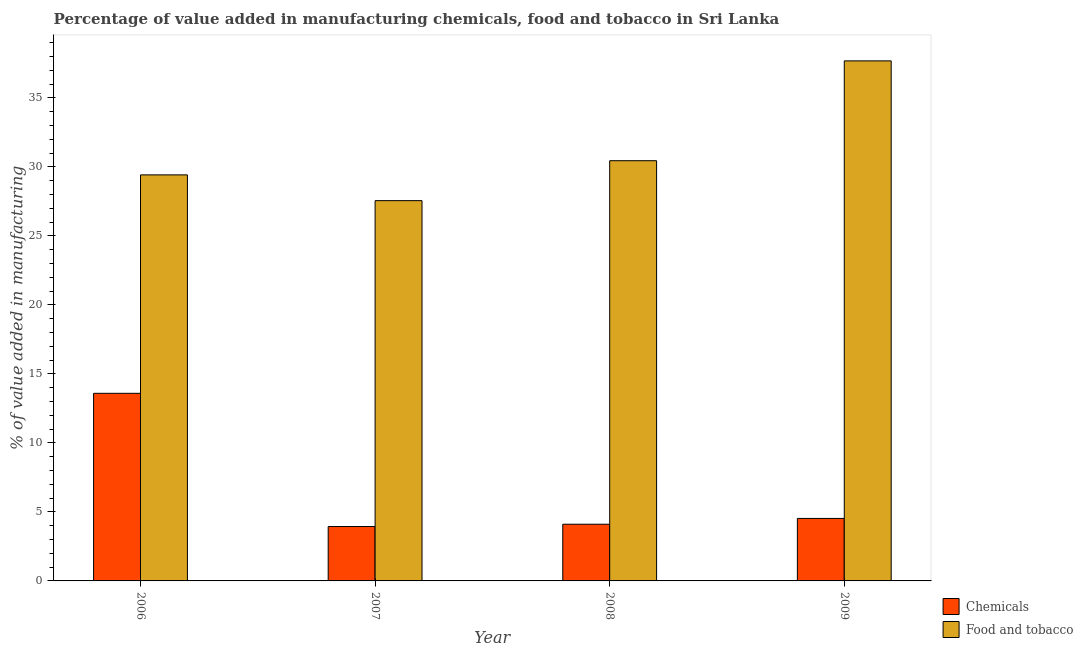Are the number of bars on each tick of the X-axis equal?
Offer a very short reply. Yes. How many bars are there on the 2nd tick from the left?
Give a very brief answer. 2. What is the label of the 1st group of bars from the left?
Give a very brief answer. 2006. In how many cases, is the number of bars for a given year not equal to the number of legend labels?
Your response must be concise. 0. What is the value added by  manufacturing chemicals in 2007?
Your answer should be compact. 3.94. Across all years, what is the maximum value added by  manufacturing chemicals?
Keep it short and to the point. 13.59. Across all years, what is the minimum value added by  manufacturing chemicals?
Provide a succinct answer. 3.94. In which year was the value added by manufacturing food and tobacco maximum?
Provide a short and direct response. 2009. In which year was the value added by manufacturing food and tobacco minimum?
Your response must be concise. 2007. What is the total value added by  manufacturing chemicals in the graph?
Your answer should be very brief. 26.17. What is the difference between the value added by  manufacturing chemicals in 2007 and that in 2009?
Make the answer very short. -0.59. What is the difference between the value added by  manufacturing chemicals in 2008 and the value added by manufacturing food and tobacco in 2007?
Make the answer very short. 0.17. What is the average value added by  manufacturing chemicals per year?
Provide a short and direct response. 6.54. In the year 2009, what is the difference between the value added by manufacturing food and tobacco and value added by  manufacturing chemicals?
Make the answer very short. 0. In how many years, is the value added by manufacturing food and tobacco greater than 15 %?
Keep it short and to the point. 4. What is the ratio of the value added by manufacturing food and tobacco in 2006 to that in 2007?
Give a very brief answer. 1.07. Is the value added by  manufacturing chemicals in 2007 less than that in 2008?
Your answer should be compact. Yes. What is the difference between the highest and the second highest value added by  manufacturing chemicals?
Your answer should be very brief. 9.06. What is the difference between the highest and the lowest value added by manufacturing food and tobacco?
Provide a succinct answer. 10.13. Is the sum of the value added by  manufacturing chemicals in 2006 and 2009 greater than the maximum value added by manufacturing food and tobacco across all years?
Provide a short and direct response. Yes. What does the 1st bar from the left in 2007 represents?
Your answer should be very brief. Chemicals. What does the 1st bar from the right in 2008 represents?
Provide a short and direct response. Food and tobacco. How many bars are there?
Give a very brief answer. 8. Are all the bars in the graph horizontal?
Your answer should be very brief. No. Does the graph contain grids?
Keep it short and to the point. No. Where does the legend appear in the graph?
Provide a succinct answer. Bottom right. How are the legend labels stacked?
Give a very brief answer. Vertical. What is the title of the graph?
Make the answer very short. Percentage of value added in manufacturing chemicals, food and tobacco in Sri Lanka. Does "Under-5(female)" appear as one of the legend labels in the graph?
Your answer should be very brief. No. What is the label or title of the Y-axis?
Your answer should be compact. % of value added in manufacturing. What is the % of value added in manufacturing in Chemicals in 2006?
Keep it short and to the point. 13.59. What is the % of value added in manufacturing in Food and tobacco in 2006?
Provide a succinct answer. 29.42. What is the % of value added in manufacturing in Chemicals in 2007?
Make the answer very short. 3.94. What is the % of value added in manufacturing of Food and tobacco in 2007?
Keep it short and to the point. 27.55. What is the % of value added in manufacturing of Chemicals in 2008?
Provide a short and direct response. 4.11. What is the % of value added in manufacturing in Food and tobacco in 2008?
Your answer should be very brief. 30.45. What is the % of value added in manufacturing in Chemicals in 2009?
Offer a very short reply. 4.53. What is the % of value added in manufacturing of Food and tobacco in 2009?
Your response must be concise. 37.68. Across all years, what is the maximum % of value added in manufacturing in Chemicals?
Ensure brevity in your answer.  13.59. Across all years, what is the maximum % of value added in manufacturing in Food and tobacco?
Give a very brief answer. 37.68. Across all years, what is the minimum % of value added in manufacturing of Chemicals?
Ensure brevity in your answer.  3.94. Across all years, what is the minimum % of value added in manufacturing of Food and tobacco?
Make the answer very short. 27.55. What is the total % of value added in manufacturing in Chemicals in the graph?
Your answer should be compact. 26.17. What is the total % of value added in manufacturing of Food and tobacco in the graph?
Your answer should be compact. 125.1. What is the difference between the % of value added in manufacturing in Chemicals in 2006 and that in 2007?
Your answer should be very brief. 9.65. What is the difference between the % of value added in manufacturing in Food and tobacco in 2006 and that in 2007?
Your response must be concise. 1.87. What is the difference between the % of value added in manufacturing of Chemicals in 2006 and that in 2008?
Your answer should be very brief. 9.49. What is the difference between the % of value added in manufacturing in Food and tobacco in 2006 and that in 2008?
Your response must be concise. -1.03. What is the difference between the % of value added in manufacturing in Chemicals in 2006 and that in 2009?
Make the answer very short. 9.06. What is the difference between the % of value added in manufacturing in Food and tobacco in 2006 and that in 2009?
Your response must be concise. -8.26. What is the difference between the % of value added in manufacturing of Chemicals in 2007 and that in 2008?
Keep it short and to the point. -0.17. What is the difference between the % of value added in manufacturing of Food and tobacco in 2007 and that in 2008?
Your answer should be very brief. -2.89. What is the difference between the % of value added in manufacturing of Chemicals in 2007 and that in 2009?
Make the answer very short. -0.59. What is the difference between the % of value added in manufacturing of Food and tobacco in 2007 and that in 2009?
Provide a succinct answer. -10.13. What is the difference between the % of value added in manufacturing of Chemicals in 2008 and that in 2009?
Your response must be concise. -0.42. What is the difference between the % of value added in manufacturing of Food and tobacco in 2008 and that in 2009?
Your response must be concise. -7.23. What is the difference between the % of value added in manufacturing in Chemicals in 2006 and the % of value added in manufacturing in Food and tobacco in 2007?
Provide a succinct answer. -13.96. What is the difference between the % of value added in manufacturing in Chemicals in 2006 and the % of value added in manufacturing in Food and tobacco in 2008?
Offer a terse response. -16.85. What is the difference between the % of value added in manufacturing of Chemicals in 2006 and the % of value added in manufacturing of Food and tobacco in 2009?
Your answer should be very brief. -24.09. What is the difference between the % of value added in manufacturing in Chemicals in 2007 and the % of value added in manufacturing in Food and tobacco in 2008?
Your answer should be compact. -26.5. What is the difference between the % of value added in manufacturing of Chemicals in 2007 and the % of value added in manufacturing of Food and tobacco in 2009?
Your answer should be very brief. -33.74. What is the difference between the % of value added in manufacturing of Chemicals in 2008 and the % of value added in manufacturing of Food and tobacco in 2009?
Ensure brevity in your answer.  -33.57. What is the average % of value added in manufacturing in Chemicals per year?
Give a very brief answer. 6.54. What is the average % of value added in manufacturing in Food and tobacco per year?
Your response must be concise. 31.27. In the year 2006, what is the difference between the % of value added in manufacturing of Chemicals and % of value added in manufacturing of Food and tobacco?
Provide a short and direct response. -15.83. In the year 2007, what is the difference between the % of value added in manufacturing of Chemicals and % of value added in manufacturing of Food and tobacco?
Your response must be concise. -23.61. In the year 2008, what is the difference between the % of value added in manufacturing of Chemicals and % of value added in manufacturing of Food and tobacco?
Your response must be concise. -26.34. In the year 2009, what is the difference between the % of value added in manufacturing of Chemicals and % of value added in manufacturing of Food and tobacco?
Offer a very short reply. -33.15. What is the ratio of the % of value added in manufacturing of Chemicals in 2006 to that in 2007?
Provide a short and direct response. 3.45. What is the ratio of the % of value added in manufacturing of Food and tobacco in 2006 to that in 2007?
Make the answer very short. 1.07. What is the ratio of the % of value added in manufacturing in Chemicals in 2006 to that in 2008?
Provide a short and direct response. 3.31. What is the ratio of the % of value added in manufacturing of Food and tobacco in 2006 to that in 2008?
Your answer should be very brief. 0.97. What is the ratio of the % of value added in manufacturing of Chemicals in 2006 to that in 2009?
Keep it short and to the point. 3. What is the ratio of the % of value added in manufacturing of Food and tobacco in 2006 to that in 2009?
Offer a very short reply. 0.78. What is the ratio of the % of value added in manufacturing in Chemicals in 2007 to that in 2008?
Your answer should be compact. 0.96. What is the ratio of the % of value added in manufacturing in Food and tobacco in 2007 to that in 2008?
Give a very brief answer. 0.91. What is the ratio of the % of value added in manufacturing in Chemicals in 2007 to that in 2009?
Make the answer very short. 0.87. What is the ratio of the % of value added in manufacturing in Food and tobacco in 2007 to that in 2009?
Ensure brevity in your answer.  0.73. What is the ratio of the % of value added in manufacturing in Chemicals in 2008 to that in 2009?
Your response must be concise. 0.91. What is the ratio of the % of value added in manufacturing in Food and tobacco in 2008 to that in 2009?
Provide a short and direct response. 0.81. What is the difference between the highest and the second highest % of value added in manufacturing of Chemicals?
Ensure brevity in your answer.  9.06. What is the difference between the highest and the second highest % of value added in manufacturing of Food and tobacco?
Ensure brevity in your answer.  7.23. What is the difference between the highest and the lowest % of value added in manufacturing in Chemicals?
Offer a terse response. 9.65. What is the difference between the highest and the lowest % of value added in manufacturing in Food and tobacco?
Provide a succinct answer. 10.13. 